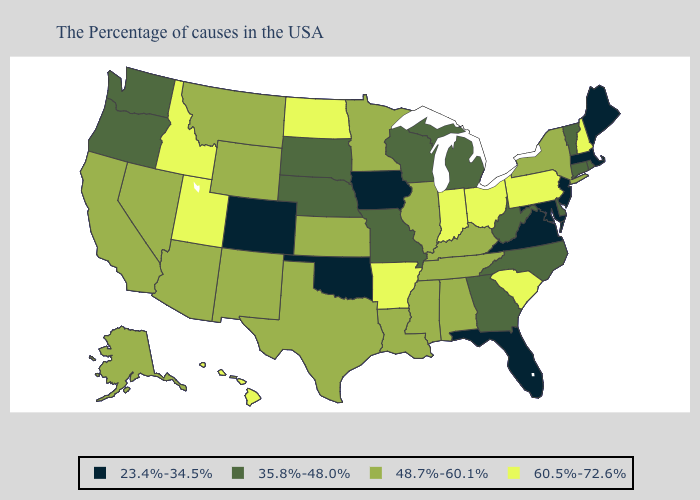Name the states that have a value in the range 48.7%-60.1%?
Write a very short answer. New York, Kentucky, Alabama, Tennessee, Illinois, Mississippi, Louisiana, Minnesota, Kansas, Texas, Wyoming, New Mexico, Montana, Arizona, Nevada, California, Alaska. Name the states that have a value in the range 23.4%-34.5%?
Keep it brief. Maine, Massachusetts, New Jersey, Maryland, Virginia, Florida, Iowa, Oklahoma, Colorado. Does Nevada have the lowest value in the West?
Quick response, please. No. Name the states that have a value in the range 48.7%-60.1%?
Concise answer only. New York, Kentucky, Alabama, Tennessee, Illinois, Mississippi, Louisiana, Minnesota, Kansas, Texas, Wyoming, New Mexico, Montana, Arizona, Nevada, California, Alaska. Name the states that have a value in the range 35.8%-48.0%?
Keep it brief. Rhode Island, Vermont, Connecticut, Delaware, North Carolina, West Virginia, Georgia, Michigan, Wisconsin, Missouri, Nebraska, South Dakota, Washington, Oregon. What is the value of Oklahoma?
Keep it brief. 23.4%-34.5%. Which states hav the highest value in the South?
Concise answer only. South Carolina, Arkansas. Does Georgia have a lower value than California?
Answer briefly. Yes. Name the states that have a value in the range 48.7%-60.1%?
Give a very brief answer. New York, Kentucky, Alabama, Tennessee, Illinois, Mississippi, Louisiana, Minnesota, Kansas, Texas, Wyoming, New Mexico, Montana, Arizona, Nevada, California, Alaska. What is the value of Massachusetts?
Quick response, please. 23.4%-34.5%. What is the value of Colorado?
Short answer required. 23.4%-34.5%. Among the states that border Georgia , does Florida have the lowest value?
Be succinct. Yes. Name the states that have a value in the range 35.8%-48.0%?
Be succinct. Rhode Island, Vermont, Connecticut, Delaware, North Carolina, West Virginia, Georgia, Michigan, Wisconsin, Missouri, Nebraska, South Dakota, Washington, Oregon. What is the value of Idaho?
Give a very brief answer. 60.5%-72.6%. Name the states that have a value in the range 35.8%-48.0%?
Concise answer only. Rhode Island, Vermont, Connecticut, Delaware, North Carolina, West Virginia, Georgia, Michigan, Wisconsin, Missouri, Nebraska, South Dakota, Washington, Oregon. 